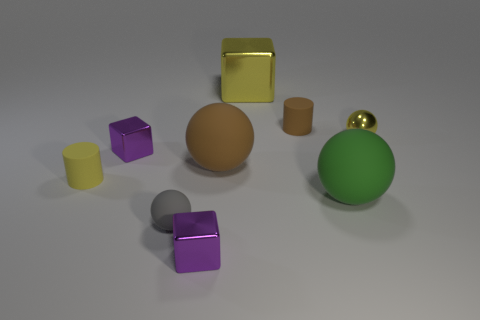Subtract all matte spheres. How many spheres are left? 1 Subtract all yellow cubes. How many cubes are left? 2 Subtract all blocks. How many objects are left? 6 Subtract 2 spheres. How many spheres are left? 2 Subtract all brown cylinders. How many purple blocks are left? 2 Subtract all big gray things. Subtract all yellow metal blocks. How many objects are left? 8 Add 6 rubber spheres. How many rubber spheres are left? 9 Add 3 small brown rubber things. How many small brown rubber things exist? 4 Subtract 0 red cylinders. How many objects are left? 9 Subtract all yellow cylinders. Subtract all yellow balls. How many cylinders are left? 1 